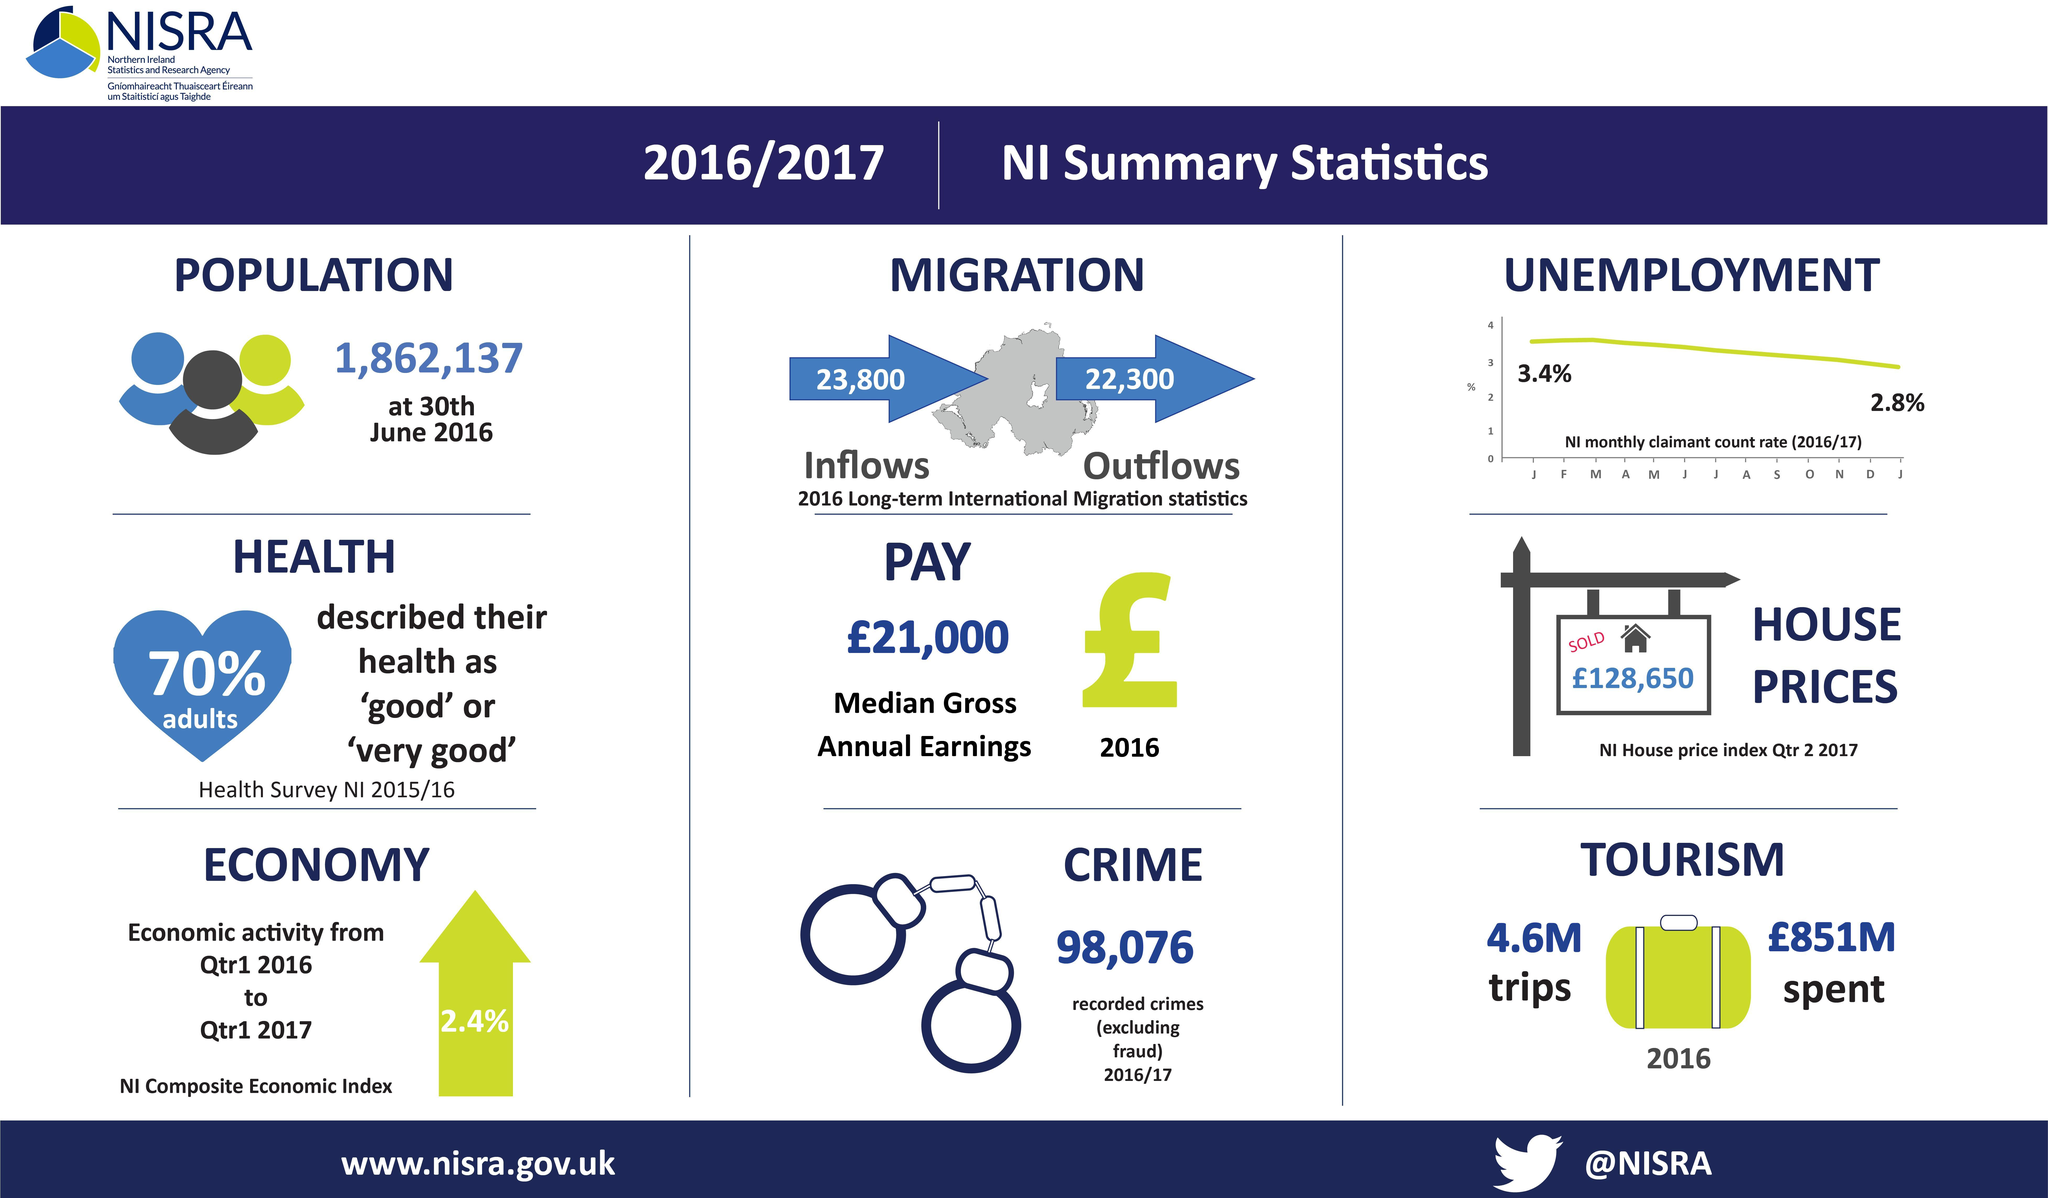How many people migrated to Northern Ireland in 2016?
Answer the question with a short phrase. 23,800 How many people left the country Northern Ireland in 2016? 22,300 What percentage of adults in NI have not marked their health condition as "good" or "very good"? 30 